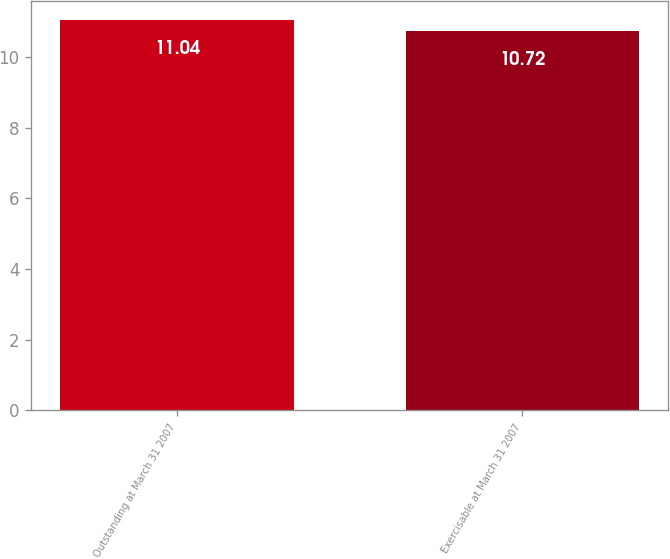Convert chart. <chart><loc_0><loc_0><loc_500><loc_500><bar_chart><fcel>Outstanding at March 31 2007<fcel>Exercisable at March 31 2007<nl><fcel>11.04<fcel>10.72<nl></chart> 